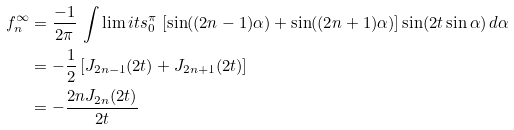<formula> <loc_0><loc_0><loc_500><loc_500>f _ { n } ^ { \infty } & = \frac { - 1 } { 2 \pi } \, \int \lim i t s _ { 0 } ^ { \pi } \, \left [ \sin ( ( 2 n - 1 ) \alpha ) + \sin ( ( 2 n + 1 ) \alpha ) \right ] \sin ( 2 t \sin \alpha ) \, d \alpha \\ & = - \frac { 1 } { 2 } \left [ J _ { 2 n - 1 } ( 2 t ) + J _ { 2 n + 1 } ( 2 t ) \right ] \\ & = - \frac { 2 n J _ { 2 n } ( 2 t ) } { 2 t }</formula> 